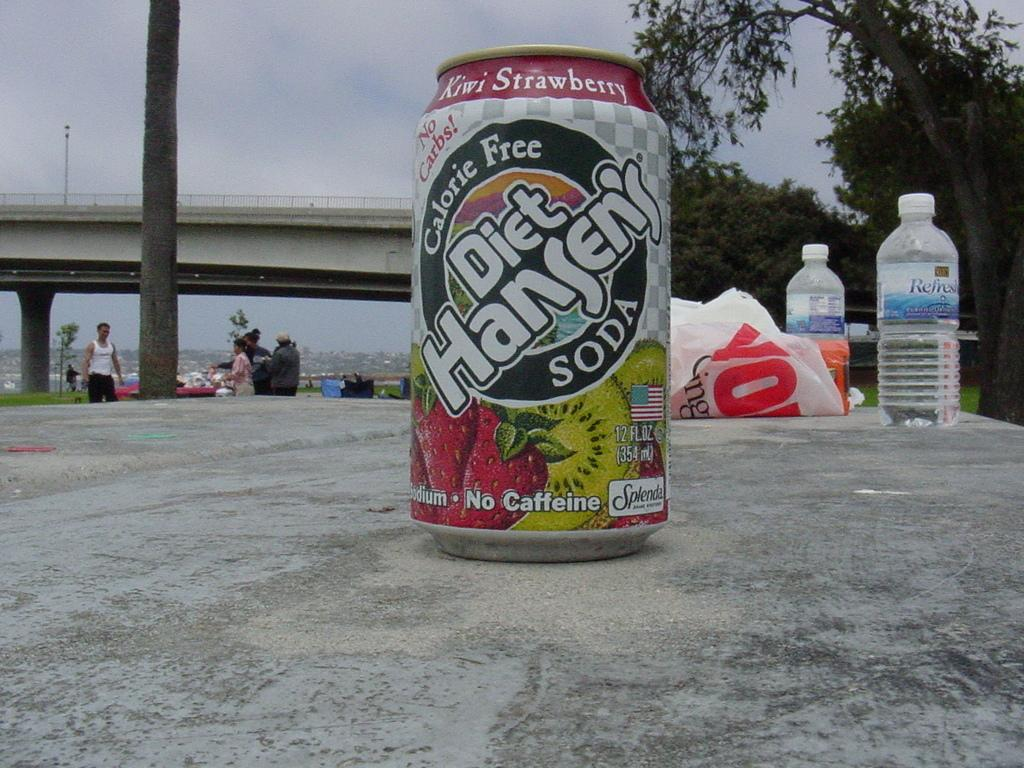<image>
Provide a brief description of the given image. A can of Diet Hansen's Soda in the Kiwi Strawberry flavor. 